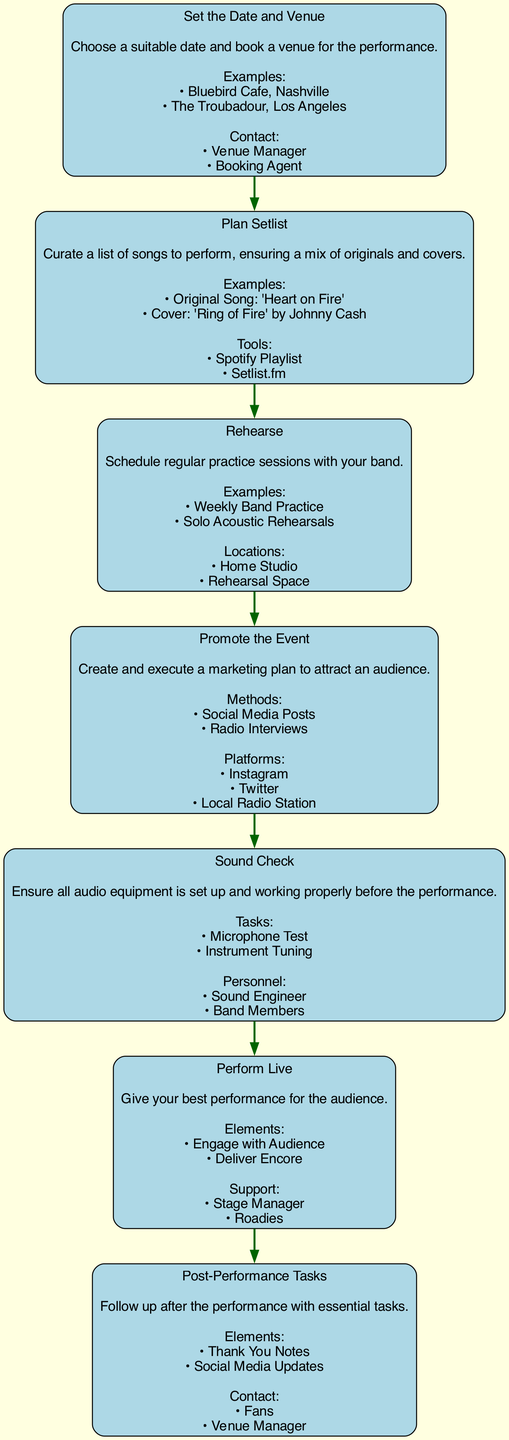What is the first step in the process? The first step in the flow chart is "Set the Date and Venue." This is identified by the first node in the diagram, which outlines the initial action required in preparing for a live performance.
Answer: Set the Date and Venue How many total steps are in the flow chart? By counting each distinct node from the diagram, there are seven steps in total, each representing a significant part of the preparation process for a live performance.
Answer: 7 Which step comes before "Promote the Event"? The step that comes before "Promote the Event" is "Rehearse." In the flow chart, nodes are connected in a top-to-bottom sequence, indicating their sequential order, with "Rehearse" directly leading into "Promote the Event."
Answer: Rehearse What key elements are included in the "Perform Live" step? The "Perform Live" step includes the elements "Engage with Audience" and "Deliver Encore." These are listed as significant components to focus on when actually performing, and they highlight important actions during the event.
Answer: Engage with Audience, Deliver Encore Which method of promotion is mentioned in the "Promote the Event" step? One of the methods mentioned in the "Promote the Event" step is "Social Media Posts." This method is outlined in the details for this step, identifying how to attract an audience effectively.
Answer: Social Media Posts What is the last task mentioned in the flow chart? The last task mentioned is "Thank You Notes," which is part of the "Post-Performance Tasks." This indicates a follow-up action that is recommended after the performance has concluded.
Answer: Thank You Notes Which personnel are involved in the "Sound Check" step? The personnel involved in the "Sound Check" step include the "Sound Engineer" and "Band Members." These roles are critical for ensuring the performance runs smoothly, as they are responsible for checking the audio setup.
Answer: Sound Engineer, Band Members How is the "Plan Setlist" step characterized in terms of its contents? The "Plan Setlist" step is characterized by its inclusion of a mix of "Originals" and "Covers." This indicates the need to create a balanced setlist that consists of both types of songs, ensuring a diverse performance for the audience.
Answer: Originals and Covers 